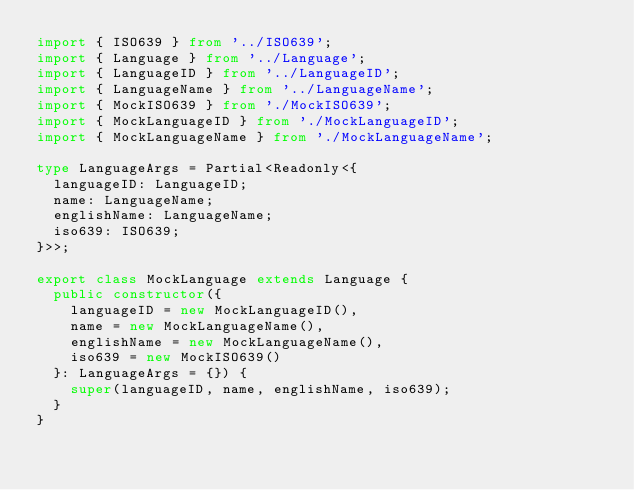Convert code to text. <code><loc_0><loc_0><loc_500><loc_500><_TypeScript_>import { ISO639 } from '../ISO639';
import { Language } from '../Language';
import { LanguageID } from '../LanguageID';
import { LanguageName } from '../LanguageName';
import { MockISO639 } from './MockISO639';
import { MockLanguageID } from './MockLanguageID';
import { MockLanguageName } from './MockLanguageName';

type LanguageArgs = Partial<Readonly<{
  languageID: LanguageID;
  name: LanguageName;
  englishName: LanguageName;
  iso639: ISO639;
}>>;

export class MockLanguage extends Language {
  public constructor({
    languageID = new MockLanguageID(),
    name = new MockLanguageName(),
    englishName = new MockLanguageName(),
    iso639 = new MockISO639()
  }: LanguageArgs = {}) {
    super(languageID, name, englishName, iso639);
  }
}
</code> 